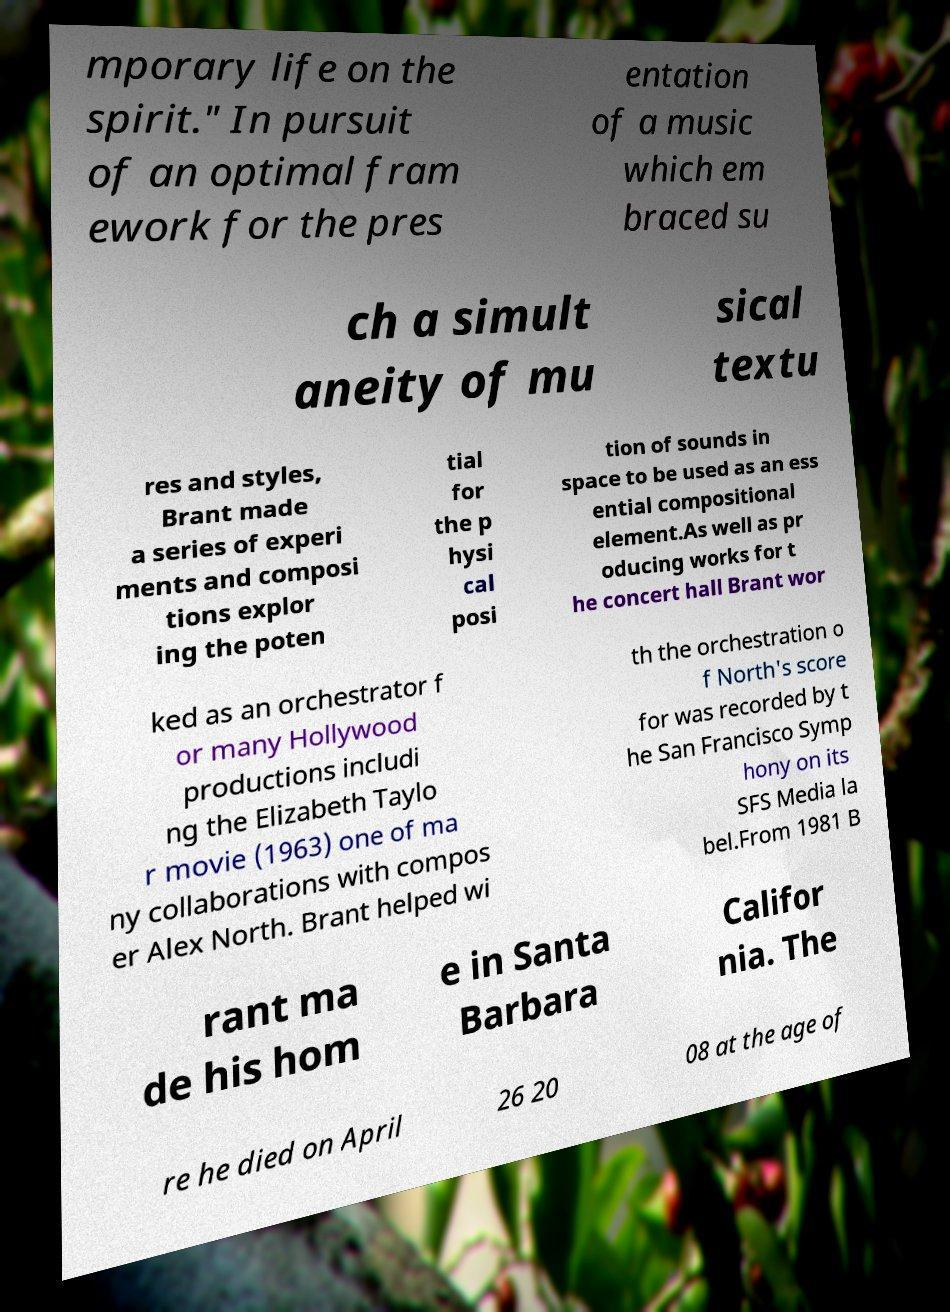For documentation purposes, I need the text within this image transcribed. Could you provide that? mporary life on the spirit." In pursuit of an optimal fram ework for the pres entation of a music which em braced su ch a simult aneity of mu sical textu res and styles, Brant made a series of experi ments and composi tions explor ing the poten tial for the p hysi cal posi tion of sounds in space to be used as an ess ential compositional element.As well as pr oducing works for t he concert hall Brant wor ked as an orchestrator f or many Hollywood productions includi ng the Elizabeth Taylo r movie (1963) one of ma ny collaborations with compos er Alex North. Brant helped wi th the orchestration o f North's score for was recorded by t he San Francisco Symp hony on its SFS Media la bel.From 1981 B rant ma de his hom e in Santa Barbara Califor nia. The re he died on April 26 20 08 at the age of 